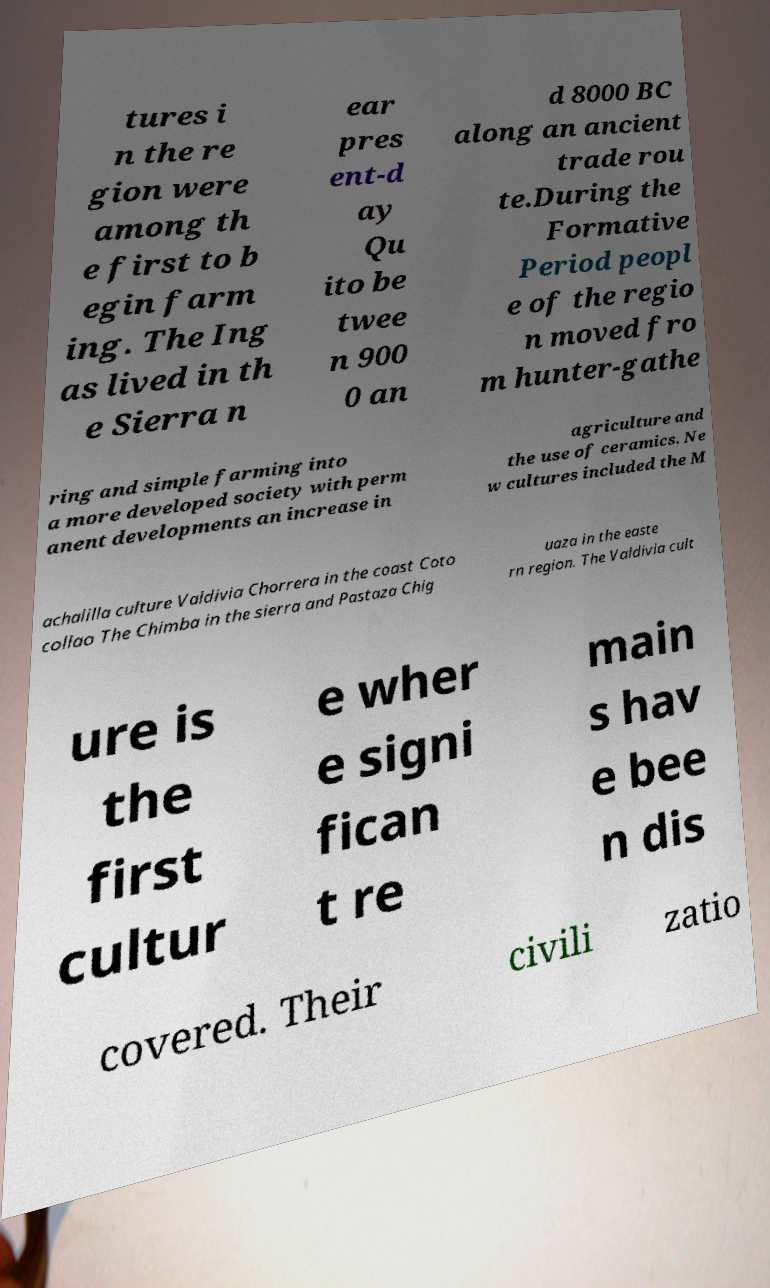I need the written content from this picture converted into text. Can you do that? tures i n the re gion were among th e first to b egin farm ing. The Ing as lived in th e Sierra n ear pres ent-d ay Qu ito be twee n 900 0 an d 8000 BC along an ancient trade rou te.During the Formative Period peopl e of the regio n moved fro m hunter-gathe ring and simple farming into a more developed society with perm anent developments an increase in agriculture and the use of ceramics. Ne w cultures included the M achalilla culture Valdivia Chorrera in the coast Coto collao The Chimba in the sierra and Pastaza Chig uaza in the easte rn region. The Valdivia cult ure is the first cultur e wher e signi fican t re main s hav e bee n dis covered. Their civili zatio 